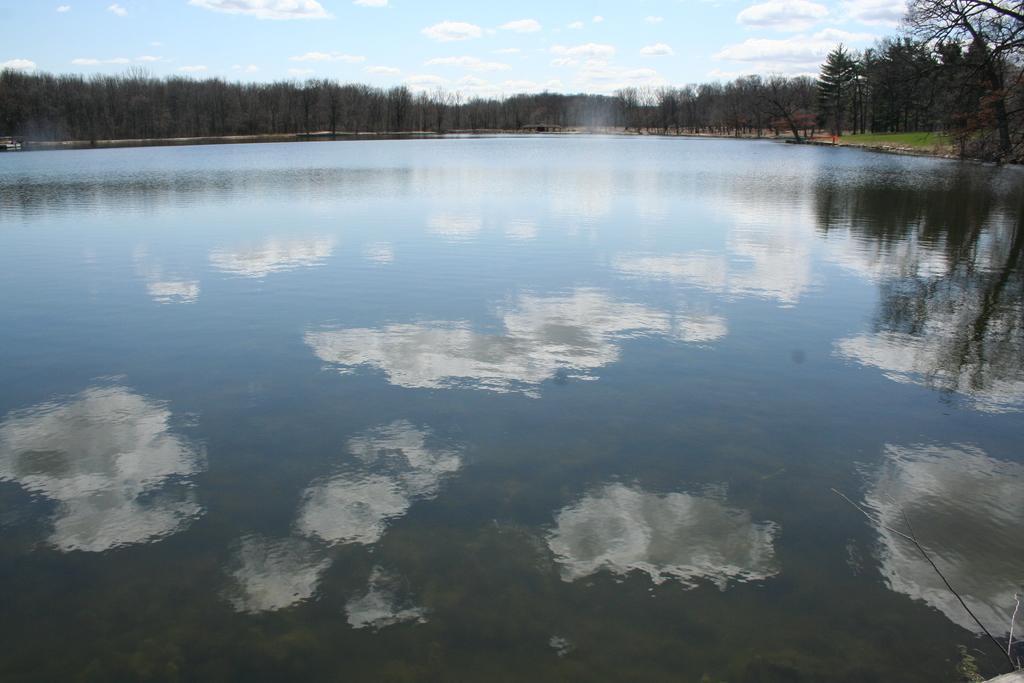In one or two sentences, can you explain what this image depicts? In this picture, we see water and this water might be in the lake. There are trees in the background. At the top of the picture, we see the sky and the clouds. 